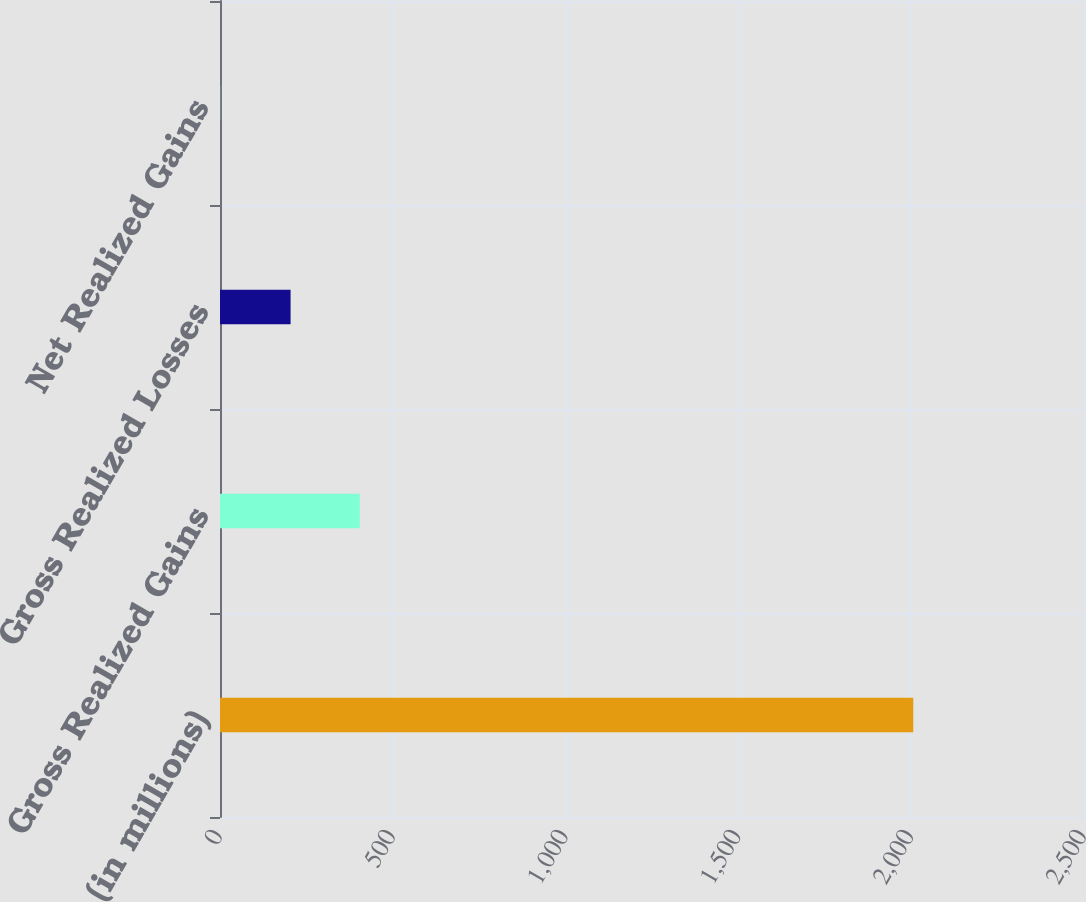<chart> <loc_0><loc_0><loc_500><loc_500><bar_chart><fcel>(in millions)<fcel>Gross Realized Gains<fcel>Gross Realized Losses<fcel>Net Realized Gains<nl><fcel>2006<fcel>404.4<fcel>204.2<fcel>4<nl></chart> 